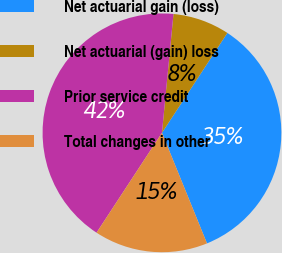Convert chart. <chart><loc_0><loc_0><loc_500><loc_500><pie_chart><fcel>Net actuarial gain (loss)<fcel>Net actuarial (gain) loss<fcel>Prior service credit<fcel>Total changes in other<nl><fcel>34.62%<fcel>7.69%<fcel>42.31%<fcel>15.38%<nl></chart> 